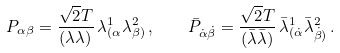<formula> <loc_0><loc_0><loc_500><loc_500>P _ { \alpha \beta } = { \frac { \sqrt { 2 } T } { ( { \lambda } { \lambda } ) } } \, \lambda _ { ( \alpha } ^ { 1 } \lambda _ { \beta ) } ^ { 2 } \, , \quad \bar { P } _ { \dot { \alpha } \dot { \beta } } = { \frac { \sqrt { 2 } T } { ( \bar { \lambda } \bar { \lambda } ) } } \, \bar { \lambda } _ { ( \dot { \alpha } } ^ { 1 } \bar { \lambda } _ { \dot { \beta } ) } ^ { 2 } \, .</formula> 